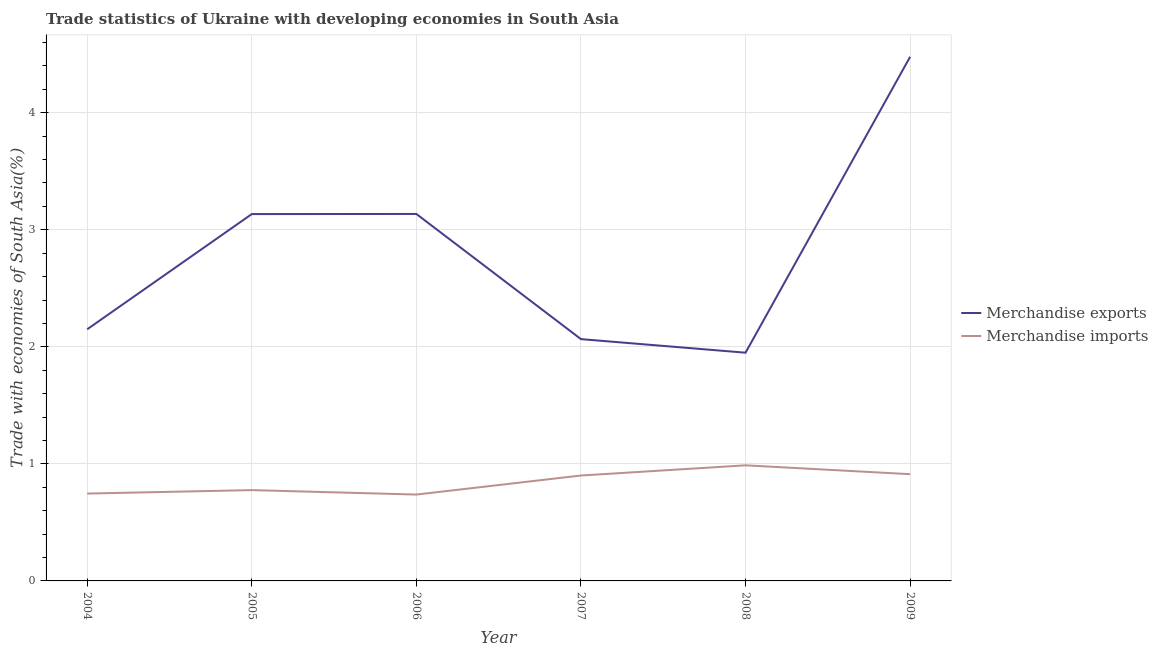How many different coloured lines are there?
Make the answer very short. 2. What is the merchandise imports in 2005?
Provide a short and direct response. 0.78. Across all years, what is the maximum merchandise exports?
Make the answer very short. 4.48. Across all years, what is the minimum merchandise exports?
Your answer should be very brief. 1.95. What is the total merchandise imports in the graph?
Provide a succinct answer. 5.06. What is the difference between the merchandise exports in 2006 and that in 2009?
Offer a terse response. -1.34. What is the difference between the merchandise imports in 2007 and the merchandise exports in 2005?
Your answer should be very brief. -2.23. What is the average merchandise exports per year?
Ensure brevity in your answer.  2.82. In the year 2007, what is the difference between the merchandise imports and merchandise exports?
Provide a short and direct response. -1.17. In how many years, is the merchandise imports greater than 2.2 %?
Offer a terse response. 0. What is the ratio of the merchandise exports in 2006 to that in 2009?
Offer a very short reply. 0.7. Is the merchandise imports in 2008 less than that in 2009?
Your response must be concise. No. What is the difference between the highest and the second highest merchandise imports?
Your answer should be very brief. 0.08. What is the difference between the highest and the lowest merchandise exports?
Make the answer very short. 2.53. In how many years, is the merchandise exports greater than the average merchandise exports taken over all years?
Provide a succinct answer. 3. Is the sum of the merchandise exports in 2004 and 2005 greater than the maximum merchandise imports across all years?
Your answer should be compact. Yes. Is the merchandise imports strictly greater than the merchandise exports over the years?
Give a very brief answer. No. Is the merchandise imports strictly less than the merchandise exports over the years?
Your response must be concise. Yes. How many lines are there?
Your answer should be very brief. 2. How many years are there in the graph?
Offer a very short reply. 6. What is the difference between two consecutive major ticks on the Y-axis?
Your answer should be very brief. 1. Does the graph contain any zero values?
Keep it short and to the point. No. Does the graph contain grids?
Give a very brief answer. Yes. Where does the legend appear in the graph?
Offer a terse response. Center right. How are the legend labels stacked?
Provide a short and direct response. Vertical. What is the title of the graph?
Provide a succinct answer. Trade statistics of Ukraine with developing economies in South Asia. Does "Travel Items" appear as one of the legend labels in the graph?
Make the answer very short. No. What is the label or title of the Y-axis?
Provide a short and direct response. Trade with economies of South Asia(%). What is the Trade with economies of South Asia(%) in Merchandise exports in 2004?
Make the answer very short. 2.15. What is the Trade with economies of South Asia(%) of Merchandise imports in 2004?
Your answer should be compact. 0.75. What is the Trade with economies of South Asia(%) in Merchandise exports in 2005?
Give a very brief answer. 3.13. What is the Trade with economies of South Asia(%) in Merchandise imports in 2005?
Your answer should be very brief. 0.78. What is the Trade with economies of South Asia(%) in Merchandise exports in 2006?
Your answer should be compact. 3.14. What is the Trade with economies of South Asia(%) of Merchandise imports in 2006?
Provide a short and direct response. 0.74. What is the Trade with economies of South Asia(%) in Merchandise exports in 2007?
Provide a short and direct response. 2.07. What is the Trade with economies of South Asia(%) in Merchandise imports in 2007?
Provide a short and direct response. 0.9. What is the Trade with economies of South Asia(%) in Merchandise exports in 2008?
Keep it short and to the point. 1.95. What is the Trade with economies of South Asia(%) of Merchandise imports in 2008?
Ensure brevity in your answer.  0.99. What is the Trade with economies of South Asia(%) in Merchandise exports in 2009?
Your answer should be compact. 4.48. What is the Trade with economies of South Asia(%) of Merchandise imports in 2009?
Offer a terse response. 0.91. Across all years, what is the maximum Trade with economies of South Asia(%) of Merchandise exports?
Keep it short and to the point. 4.48. Across all years, what is the maximum Trade with economies of South Asia(%) of Merchandise imports?
Your response must be concise. 0.99. Across all years, what is the minimum Trade with economies of South Asia(%) in Merchandise exports?
Keep it short and to the point. 1.95. Across all years, what is the minimum Trade with economies of South Asia(%) in Merchandise imports?
Provide a short and direct response. 0.74. What is the total Trade with economies of South Asia(%) of Merchandise exports in the graph?
Provide a succinct answer. 16.91. What is the total Trade with economies of South Asia(%) in Merchandise imports in the graph?
Keep it short and to the point. 5.06. What is the difference between the Trade with economies of South Asia(%) in Merchandise exports in 2004 and that in 2005?
Your response must be concise. -0.98. What is the difference between the Trade with economies of South Asia(%) in Merchandise imports in 2004 and that in 2005?
Your response must be concise. -0.03. What is the difference between the Trade with economies of South Asia(%) in Merchandise exports in 2004 and that in 2006?
Your response must be concise. -0.99. What is the difference between the Trade with economies of South Asia(%) of Merchandise imports in 2004 and that in 2006?
Your response must be concise. 0.01. What is the difference between the Trade with economies of South Asia(%) in Merchandise exports in 2004 and that in 2007?
Keep it short and to the point. 0.08. What is the difference between the Trade with economies of South Asia(%) in Merchandise imports in 2004 and that in 2007?
Ensure brevity in your answer.  -0.15. What is the difference between the Trade with economies of South Asia(%) of Merchandise exports in 2004 and that in 2008?
Your answer should be very brief. 0.2. What is the difference between the Trade with economies of South Asia(%) of Merchandise imports in 2004 and that in 2008?
Offer a terse response. -0.24. What is the difference between the Trade with economies of South Asia(%) in Merchandise exports in 2004 and that in 2009?
Offer a terse response. -2.33. What is the difference between the Trade with economies of South Asia(%) in Merchandise imports in 2004 and that in 2009?
Give a very brief answer. -0.17. What is the difference between the Trade with economies of South Asia(%) of Merchandise exports in 2005 and that in 2006?
Your response must be concise. -0. What is the difference between the Trade with economies of South Asia(%) of Merchandise imports in 2005 and that in 2006?
Provide a succinct answer. 0.04. What is the difference between the Trade with economies of South Asia(%) of Merchandise exports in 2005 and that in 2007?
Your response must be concise. 1.07. What is the difference between the Trade with economies of South Asia(%) in Merchandise imports in 2005 and that in 2007?
Provide a short and direct response. -0.12. What is the difference between the Trade with economies of South Asia(%) in Merchandise exports in 2005 and that in 2008?
Your answer should be compact. 1.18. What is the difference between the Trade with economies of South Asia(%) of Merchandise imports in 2005 and that in 2008?
Your answer should be very brief. -0.21. What is the difference between the Trade with economies of South Asia(%) of Merchandise exports in 2005 and that in 2009?
Ensure brevity in your answer.  -1.34. What is the difference between the Trade with economies of South Asia(%) in Merchandise imports in 2005 and that in 2009?
Provide a short and direct response. -0.14. What is the difference between the Trade with economies of South Asia(%) of Merchandise exports in 2006 and that in 2007?
Your answer should be compact. 1.07. What is the difference between the Trade with economies of South Asia(%) of Merchandise imports in 2006 and that in 2007?
Keep it short and to the point. -0.16. What is the difference between the Trade with economies of South Asia(%) of Merchandise exports in 2006 and that in 2008?
Your answer should be very brief. 1.19. What is the difference between the Trade with economies of South Asia(%) in Merchandise imports in 2006 and that in 2008?
Offer a very short reply. -0.25. What is the difference between the Trade with economies of South Asia(%) of Merchandise exports in 2006 and that in 2009?
Keep it short and to the point. -1.34. What is the difference between the Trade with economies of South Asia(%) of Merchandise imports in 2006 and that in 2009?
Your answer should be compact. -0.17. What is the difference between the Trade with economies of South Asia(%) in Merchandise exports in 2007 and that in 2008?
Your answer should be very brief. 0.12. What is the difference between the Trade with economies of South Asia(%) of Merchandise imports in 2007 and that in 2008?
Offer a very short reply. -0.09. What is the difference between the Trade with economies of South Asia(%) in Merchandise exports in 2007 and that in 2009?
Your answer should be compact. -2.41. What is the difference between the Trade with economies of South Asia(%) in Merchandise imports in 2007 and that in 2009?
Ensure brevity in your answer.  -0.01. What is the difference between the Trade with economies of South Asia(%) of Merchandise exports in 2008 and that in 2009?
Your response must be concise. -2.53. What is the difference between the Trade with economies of South Asia(%) of Merchandise imports in 2008 and that in 2009?
Provide a succinct answer. 0.08. What is the difference between the Trade with economies of South Asia(%) in Merchandise exports in 2004 and the Trade with economies of South Asia(%) in Merchandise imports in 2005?
Provide a succinct answer. 1.37. What is the difference between the Trade with economies of South Asia(%) in Merchandise exports in 2004 and the Trade with economies of South Asia(%) in Merchandise imports in 2006?
Make the answer very short. 1.41. What is the difference between the Trade with economies of South Asia(%) of Merchandise exports in 2004 and the Trade with economies of South Asia(%) of Merchandise imports in 2007?
Provide a short and direct response. 1.25. What is the difference between the Trade with economies of South Asia(%) of Merchandise exports in 2004 and the Trade with economies of South Asia(%) of Merchandise imports in 2008?
Offer a very short reply. 1.16. What is the difference between the Trade with economies of South Asia(%) in Merchandise exports in 2004 and the Trade with economies of South Asia(%) in Merchandise imports in 2009?
Your response must be concise. 1.24. What is the difference between the Trade with economies of South Asia(%) in Merchandise exports in 2005 and the Trade with economies of South Asia(%) in Merchandise imports in 2006?
Provide a succinct answer. 2.4. What is the difference between the Trade with economies of South Asia(%) in Merchandise exports in 2005 and the Trade with economies of South Asia(%) in Merchandise imports in 2007?
Make the answer very short. 2.23. What is the difference between the Trade with economies of South Asia(%) of Merchandise exports in 2005 and the Trade with economies of South Asia(%) of Merchandise imports in 2008?
Offer a very short reply. 2.15. What is the difference between the Trade with economies of South Asia(%) of Merchandise exports in 2005 and the Trade with economies of South Asia(%) of Merchandise imports in 2009?
Ensure brevity in your answer.  2.22. What is the difference between the Trade with economies of South Asia(%) in Merchandise exports in 2006 and the Trade with economies of South Asia(%) in Merchandise imports in 2007?
Your answer should be very brief. 2.23. What is the difference between the Trade with economies of South Asia(%) in Merchandise exports in 2006 and the Trade with economies of South Asia(%) in Merchandise imports in 2008?
Offer a very short reply. 2.15. What is the difference between the Trade with economies of South Asia(%) in Merchandise exports in 2006 and the Trade with economies of South Asia(%) in Merchandise imports in 2009?
Offer a very short reply. 2.22. What is the difference between the Trade with economies of South Asia(%) of Merchandise exports in 2007 and the Trade with economies of South Asia(%) of Merchandise imports in 2008?
Provide a succinct answer. 1.08. What is the difference between the Trade with economies of South Asia(%) of Merchandise exports in 2007 and the Trade with economies of South Asia(%) of Merchandise imports in 2009?
Make the answer very short. 1.15. What is the difference between the Trade with economies of South Asia(%) of Merchandise exports in 2008 and the Trade with economies of South Asia(%) of Merchandise imports in 2009?
Ensure brevity in your answer.  1.04. What is the average Trade with economies of South Asia(%) of Merchandise exports per year?
Offer a very short reply. 2.82. What is the average Trade with economies of South Asia(%) in Merchandise imports per year?
Make the answer very short. 0.84. In the year 2004, what is the difference between the Trade with economies of South Asia(%) in Merchandise exports and Trade with economies of South Asia(%) in Merchandise imports?
Offer a terse response. 1.4. In the year 2005, what is the difference between the Trade with economies of South Asia(%) in Merchandise exports and Trade with economies of South Asia(%) in Merchandise imports?
Offer a very short reply. 2.36. In the year 2006, what is the difference between the Trade with economies of South Asia(%) in Merchandise exports and Trade with economies of South Asia(%) in Merchandise imports?
Give a very brief answer. 2.4. In the year 2007, what is the difference between the Trade with economies of South Asia(%) of Merchandise exports and Trade with economies of South Asia(%) of Merchandise imports?
Provide a succinct answer. 1.17. In the year 2008, what is the difference between the Trade with economies of South Asia(%) in Merchandise exports and Trade with economies of South Asia(%) in Merchandise imports?
Ensure brevity in your answer.  0.96. In the year 2009, what is the difference between the Trade with economies of South Asia(%) of Merchandise exports and Trade with economies of South Asia(%) of Merchandise imports?
Provide a succinct answer. 3.57. What is the ratio of the Trade with economies of South Asia(%) of Merchandise exports in 2004 to that in 2005?
Offer a terse response. 0.69. What is the ratio of the Trade with economies of South Asia(%) of Merchandise exports in 2004 to that in 2006?
Provide a short and direct response. 0.69. What is the ratio of the Trade with economies of South Asia(%) in Merchandise imports in 2004 to that in 2006?
Give a very brief answer. 1.01. What is the ratio of the Trade with economies of South Asia(%) of Merchandise exports in 2004 to that in 2007?
Provide a short and direct response. 1.04. What is the ratio of the Trade with economies of South Asia(%) of Merchandise imports in 2004 to that in 2007?
Your answer should be compact. 0.83. What is the ratio of the Trade with economies of South Asia(%) of Merchandise exports in 2004 to that in 2008?
Your response must be concise. 1.1. What is the ratio of the Trade with economies of South Asia(%) in Merchandise imports in 2004 to that in 2008?
Provide a succinct answer. 0.76. What is the ratio of the Trade with economies of South Asia(%) of Merchandise exports in 2004 to that in 2009?
Your response must be concise. 0.48. What is the ratio of the Trade with economies of South Asia(%) of Merchandise imports in 2004 to that in 2009?
Provide a succinct answer. 0.82. What is the ratio of the Trade with economies of South Asia(%) in Merchandise imports in 2005 to that in 2006?
Your answer should be compact. 1.05. What is the ratio of the Trade with economies of South Asia(%) of Merchandise exports in 2005 to that in 2007?
Your response must be concise. 1.52. What is the ratio of the Trade with economies of South Asia(%) in Merchandise imports in 2005 to that in 2007?
Your answer should be compact. 0.86. What is the ratio of the Trade with economies of South Asia(%) of Merchandise exports in 2005 to that in 2008?
Provide a succinct answer. 1.61. What is the ratio of the Trade with economies of South Asia(%) in Merchandise imports in 2005 to that in 2008?
Offer a very short reply. 0.79. What is the ratio of the Trade with economies of South Asia(%) of Merchandise exports in 2005 to that in 2009?
Offer a terse response. 0.7. What is the ratio of the Trade with economies of South Asia(%) in Merchandise imports in 2005 to that in 2009?
Offer a terse response. 0.85. What is the ratio of the Trade with economies of South Asia(%) of Merchandise exports in 2006 to that in 2007?
Ensure brevity in your answer.  1.52. What is the ratio of the Trade with economies of South Asia(%) in Merchandise imports in 2006 to that in 2007?
Your answer should be very brief. 0.82. What is the ratio of the Trade with economies of South Asia(%) of Merchandise exports in 2006 to that in 2008?
Ensure brevity in your answer.  1.61. What is the ratio of the Trade with economies of South Asia(%) of Merchandise imports in 2006 to that in 2008?
Provide a succinct answer. 0.75. What is the ratio of the Trade with economies of South Asia(%) in Merchandise exports in 2006 to that in 2009?
Your answer should be very brief. 0.7. What is the ratio of the Trade with economies of South Asia(%) of Merchandise imports in 2006 to that in 2009?
Provide a short and direct response. 0.81. What is the ratio of the Trade with economies of South Asia(%) in Merchandise exports in 2007 to that in 2008?
Ensure brevity in your answer.  1.06. What is the ratio of the Trade with economies of South Asia(%) in Merchandise imports in 2007 to that in 2008?
Ensure brevity in your answer.  0.91. What is the ratio of the Trade with economies of South Asia(%) of Merchandise exports in 2007 to that in 2009?
Your answer should be compact. 0.46. What is the ratio of the Trade with economies of South Asia(%) of Merchandise imports in 2007 to that in 2009?
Provide a short and direct response. 0.99. What is the ratio of the Trade with economies of South Asia(%) of Merchandise exports in 2008 to that in 2009?
Offer a very short reply. 0.44. What is the ratio of the Trade with economies of South Asia(%) of Merchandise imports in 2008 to that in 2009?
Offer a terse response. 1.08. What is the difference between the highest and the second highest Trade with economies of South Asia(%) of Merchandise exports?
Give a very brief answer. 1.34. What is the difference between the highest and the second highest Trade with economies of South Asia(%) in Merchandise imports?
Provide a succinct answer. 0.08. What is the difference between the highest and the lowest Trade with economies of South Asia(%) in Merchandise exports?
Provide a short and direct response. 2.53. What is the difference between the highest and the lowest Trade with economies of South Asia(%) in Merchandise imports?
Make the answer very short. 0.25. 